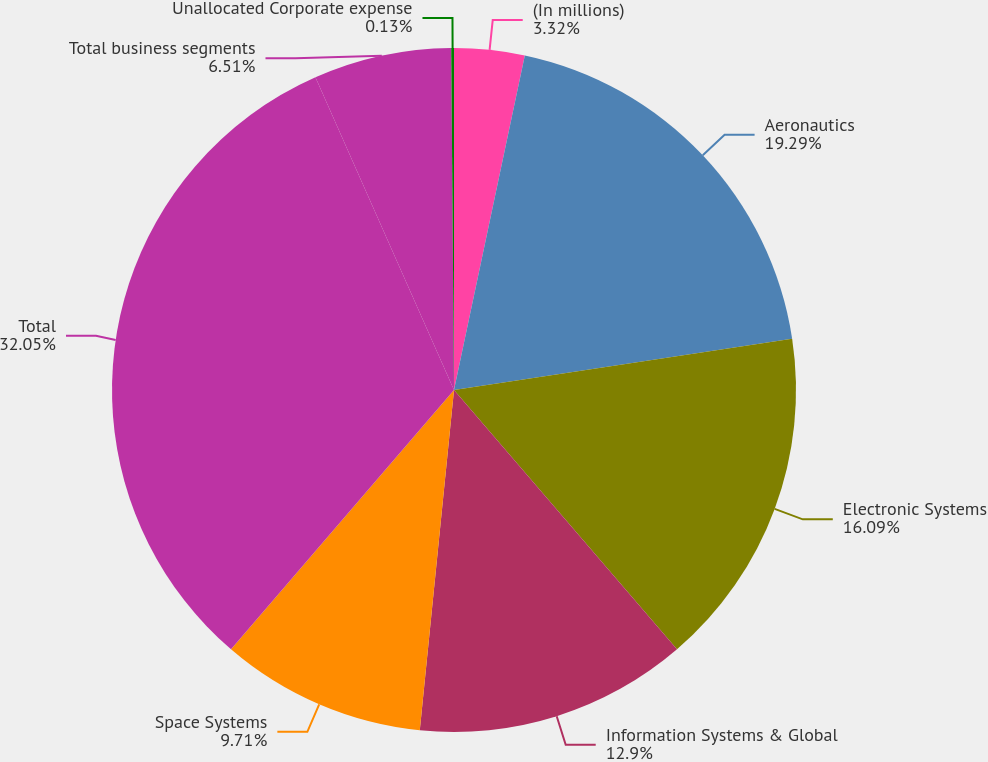Convert chart. <chart><loc_0><loc_0><loc_500><loc_500><pie_chart><fcel>(In millions)<fcel>Aeronautics<fcel>Electronic Systems<fcel>Information Systems & Global<fcel>Space Systems<fcel>Total<fcel>Total business segments<fcel>Unallocated Corporate expense<nl><fcel>3.32%<fcel>19.29%<fcel>16.09%<fcel>12.9%<fcel>9.71%<fcel>32.06%<fcel>6.51%<fcel>0.13%<nl></chart> 